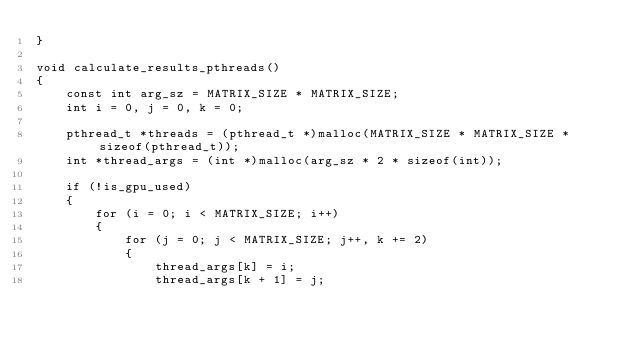Convert code to text. <code><loc_0><loc_0><loc_500><loc_500><_Cuda_>}

void calculate_results_pthreads()
{
	const int arg_sz = MATRIX_SIZE * MATRIX_SIZE;
	int i = 0, j = 0, k = 0;

	pthread_t *threads = (pthread_t *)malloc(MATRIX_SIZE * MATRIX_SIZE * sizeof(pthread_t));
	int *thread_args = (int *)malloc(arg_sz * 2 * sizeof(int));

	if (!is_gpu_used)
	{
		for (i = 0; i < MATRIX_SIZE; i++)
		{
			for (j = 0; j < MATRIX_SIZE; j++, k += 2)
			{
				thread_args[k] = i;
				thread_args[k + 1] = j;</code> 